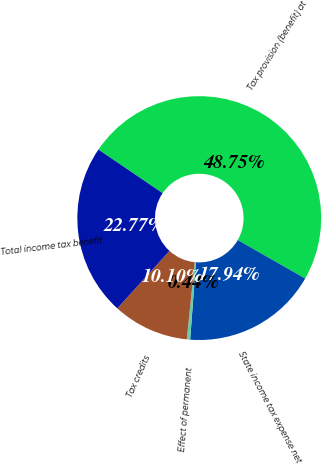Convert chart. <chart><loc_0><loc_0><loc_500><loc_500><pie_chart><fcel>Tax provision (benefit) at<fcel>State income tax expense net<fcel>Effect of permanent<fcel>Tax credits<fcel>Total income tax benefit<nl><fcel>48.75%<fcel>17.94%<fcel>0.44%<fcel>10.1%<fcel>22.77%<nl></chart> 